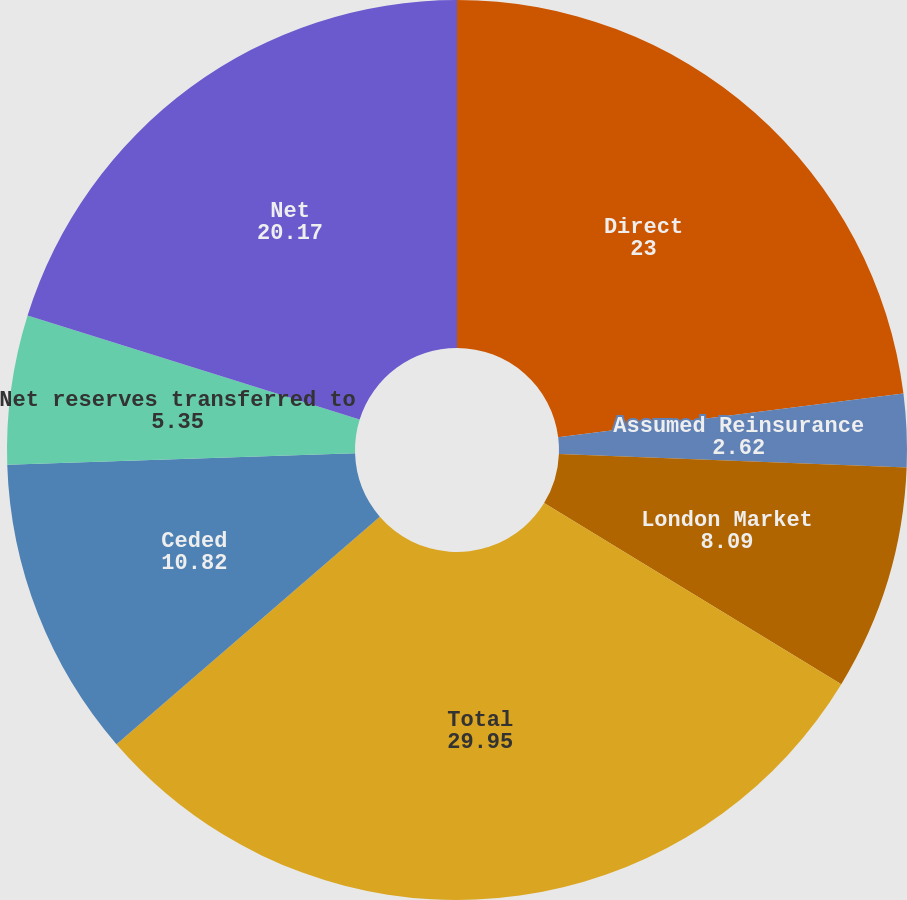Convert chart. <chart><loc_0><loc_0><loc_500><loc_500><pie_chart><fcel>Direct<fcel>Assumed Reinsurance<fcel>London Market<fcel>Total<fcel>Ceded<fcel>Net reserves transferred to<fcel>Net<nl><fcel>23.0%<fcel>2.62%<fcel>8.09%<fcel>29.95%<fcel>10.82%<fcel>5.35%<fcel>20.17%<nl></chart> 